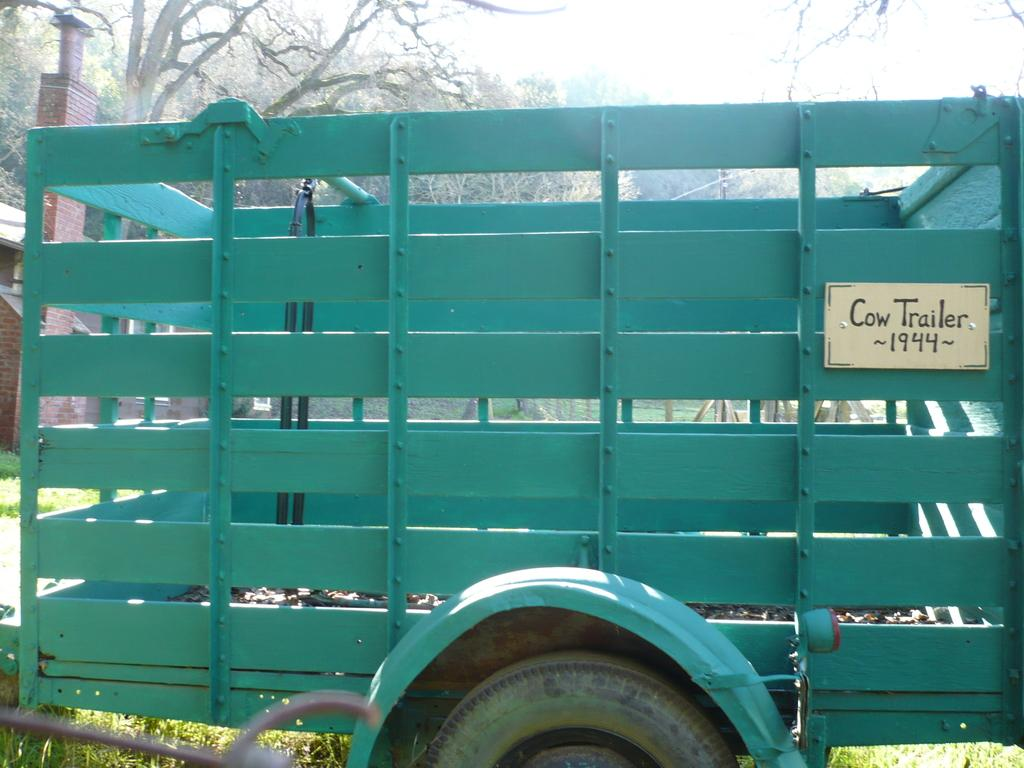What is the main subject in the center of the image? There is a vehicle in the center of the image. What else can be seen in the image besides the vehicle? There is a board with text and trees in the background of the image. What other structures are visible in the background? There is a shed in the background of the image. What is visible at the bottom of the image? The ground is visible at the bottom of the image. What type of silk is being used to cover the vehicle in the image? There is no silk present in the image, and the vehicle is not covered. What month is depicted in the image? The image does not depict a specific month; it is a static scene. 